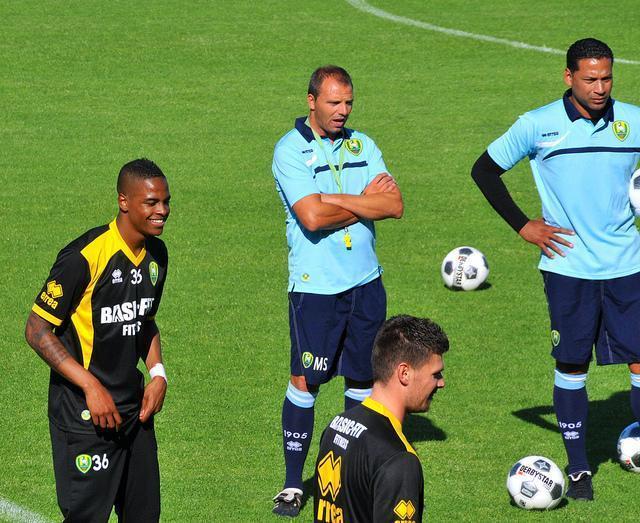How many people can be seen?
Give a very brief answer. 4. How many sandwiches with tomato are there?
Give a very brief answer. 0. 